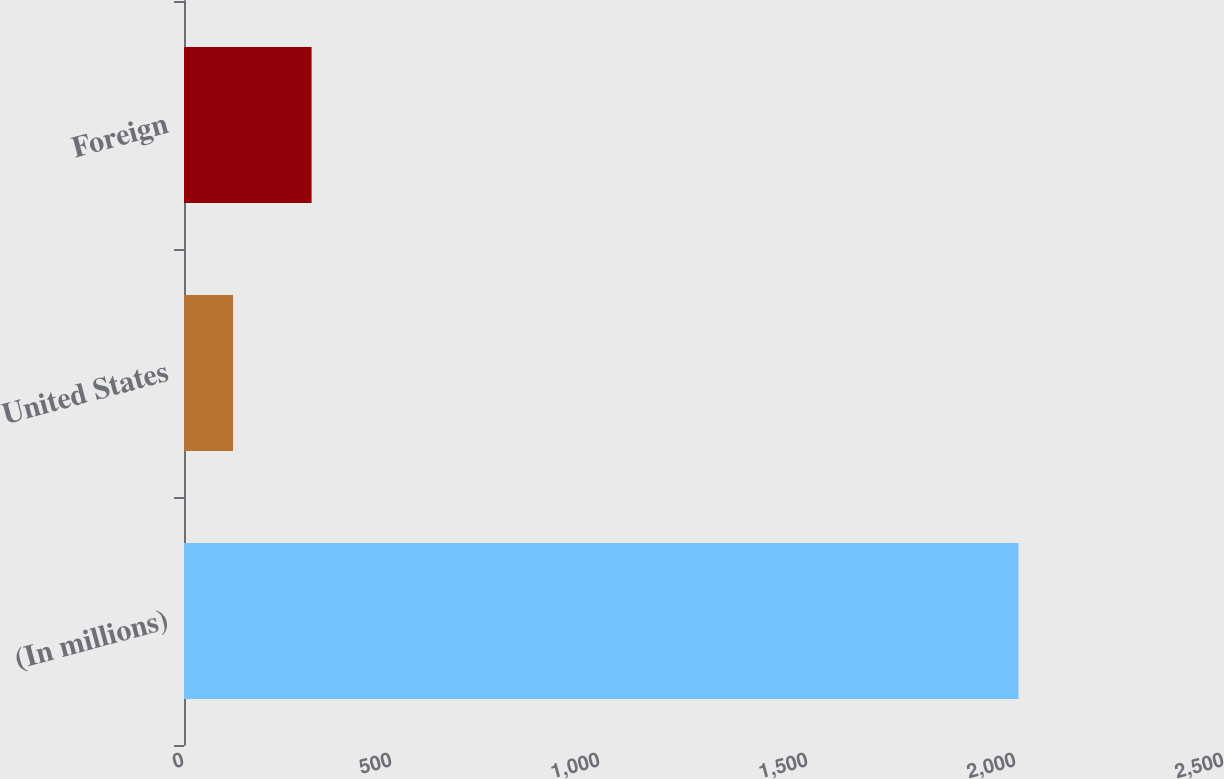Convert chart to OTSL. <chart><loc_0><loc_0><loc_500><loc_500><bar_chart><fcel>(In millions)<fcel>United States<fcel>Foreign<nl><fcel>2006<fcel>117.9<fcel>306.71<nl></chart> 